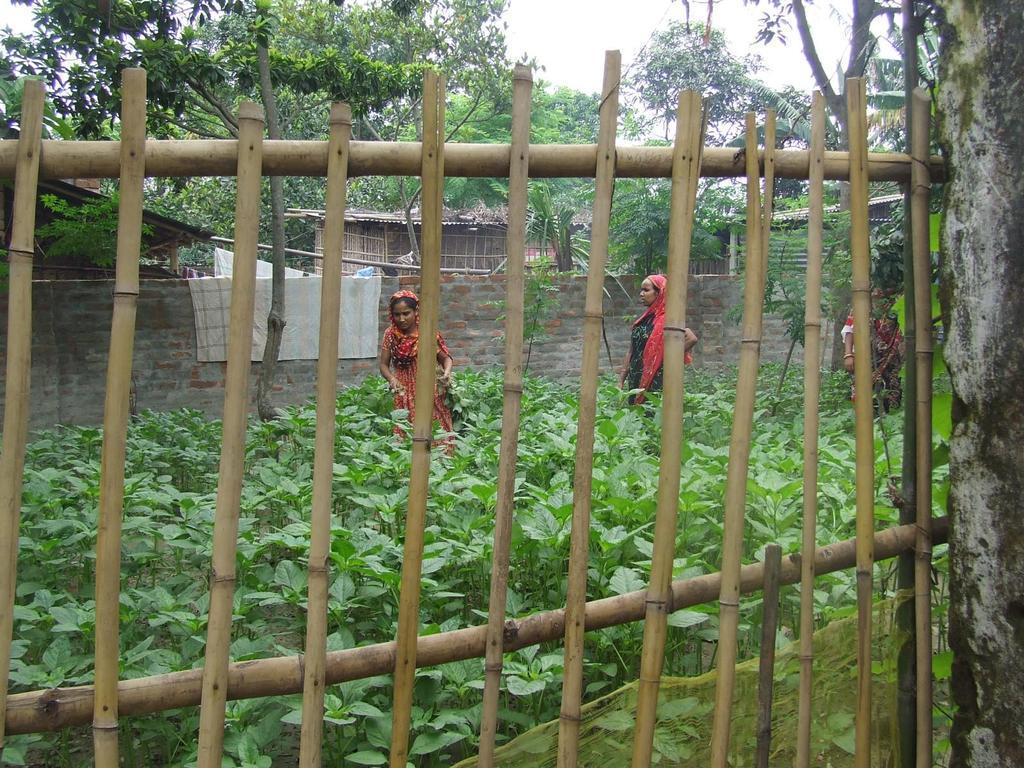Please provide a concise description of this image. In the foreground I can see a fence, three women's and plants. In the background I can see houses, trees and the sky. This image is taken may be during a day. 